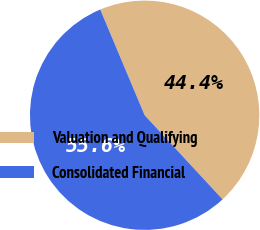Convert chart to OTSL. <chart><loc_0><loc_0><loc_500><loc_500><pie_chart><fcel>Valuation and Qualifying<fcel>Consolidated Financial<nl><fcel>44.44%<fcel>55.56%<nl></chart> 